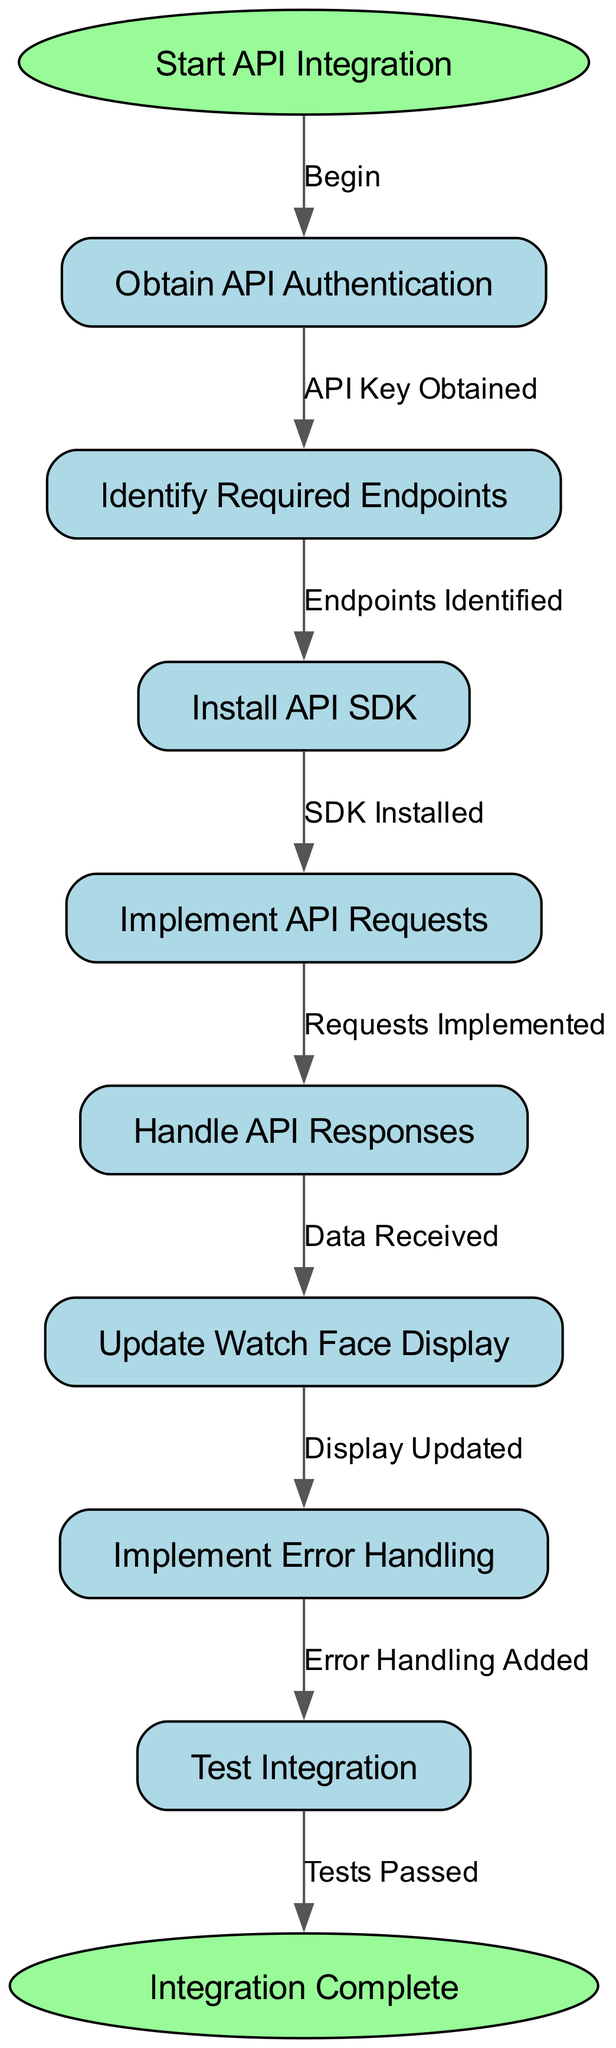What is the first step in the API integration process? The first node in the flowchart is labeled "Start API Integration," indicating that this is where the process begins.
Answer: Start API Integration How many total nodes are present in the diagram? By counting all the nodes listed in the data, including the start and end nodes, we identify a total of 10 nodes.
Answer: 10 What node follows the "Obtain API Authentication" step? The flowchart clearly shows that after "Obtain API Authentication," the next step is "Identify Required Endpoints."
Answer: Identify Required Endpoints What action occurs after implementing API requests? According to the flowchart, after "Implement API Requests," the next action is "Handle API Responses."
Answer: Handle API Responses What is the relationship between "Update Watch Face Display" and "Implement Error Handling"? The flowchart indicates that "Update Watch Face Display" leads to "Implement Error Handling," signifying that after the display update, error handling is added next.
Answer: Implement Error Handling What is the total number of edges in the diagram? Counting the directed connections (edges) established between the nodes, there are 9 edges in the flowchart.
Answer: 9 What must be done before testing the integration? Prior to the "Test Integration" step, the flowchart specifies that "Implement Error Handling" must be completed.
Answer: Implement Error Handling Which node marks the completion of the integration process? The last node in the flowchart, labeled "Integration Complete," signifies the end of the entire integration process.
Answer: Integration Complete What is the step directly prior to "Data Received"? The node that comes right before "Data Received" is "Implement API Requests," outlining that requests must be implemented to receive data.
Answer: Implement API Requests 